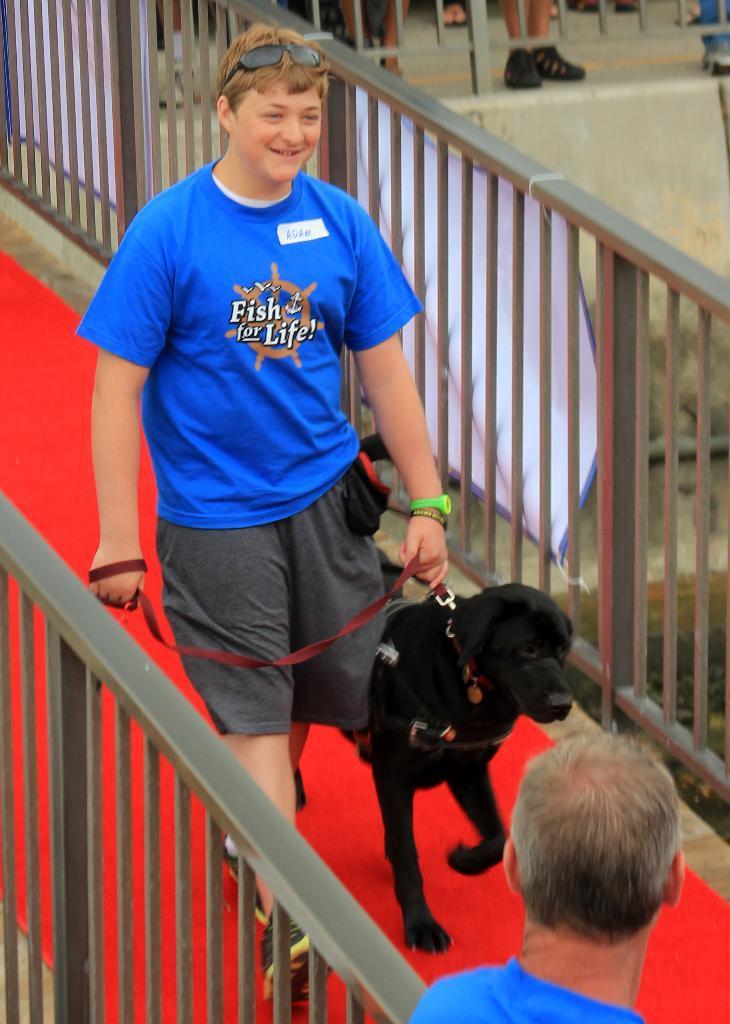How would you summarize this image in a sentence or two? In this picture we can see a man smiling and holding rope with his hand of a dog beside him and he is walking on a bridge with fence and in the background we can see banners, some persons legs and in front man. 